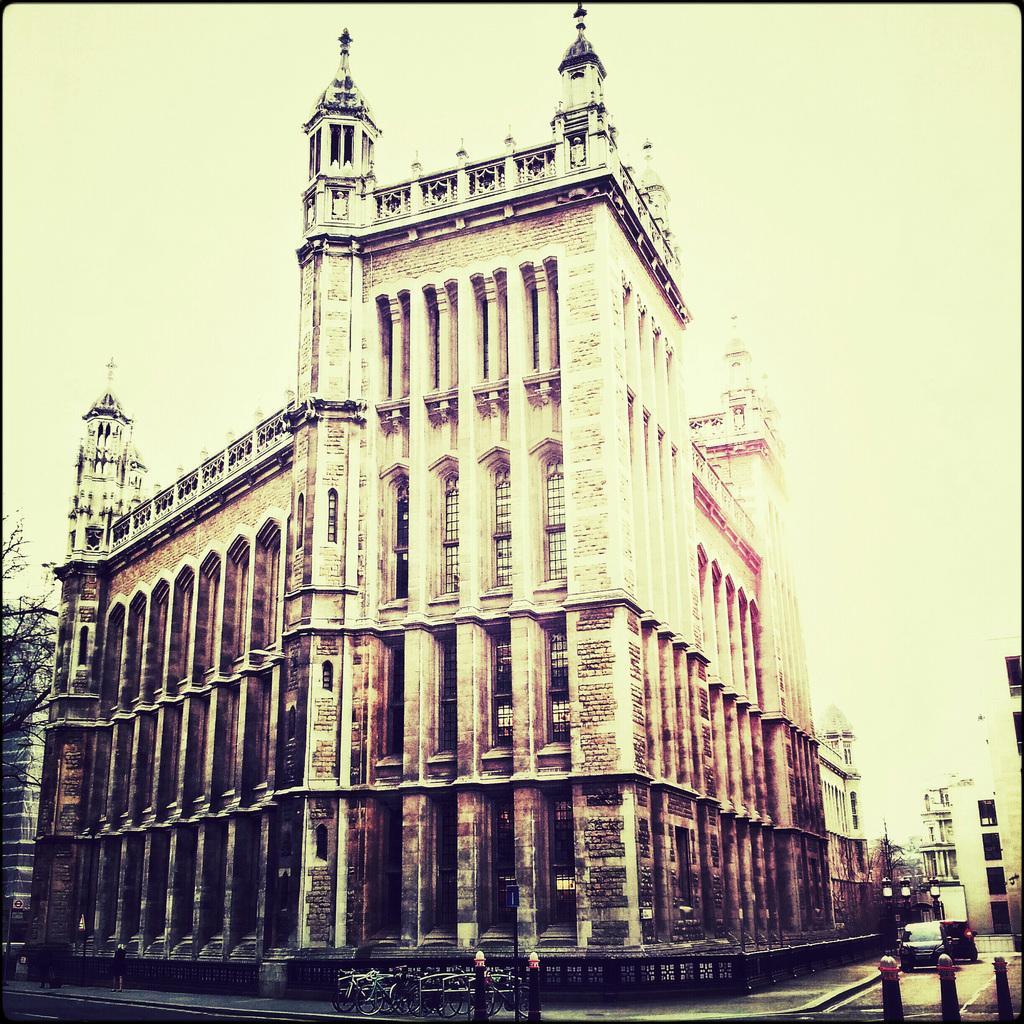Please provide a concise description of this image. In the picture I can see buildings, a tree, poles, bicycles, vehicles on road and some other objects on the ground. In the background I can see the sky. 